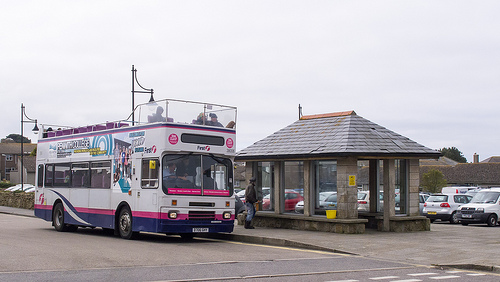What is the vehicle on the pavement? The vehicle on the pavement is a bus. 